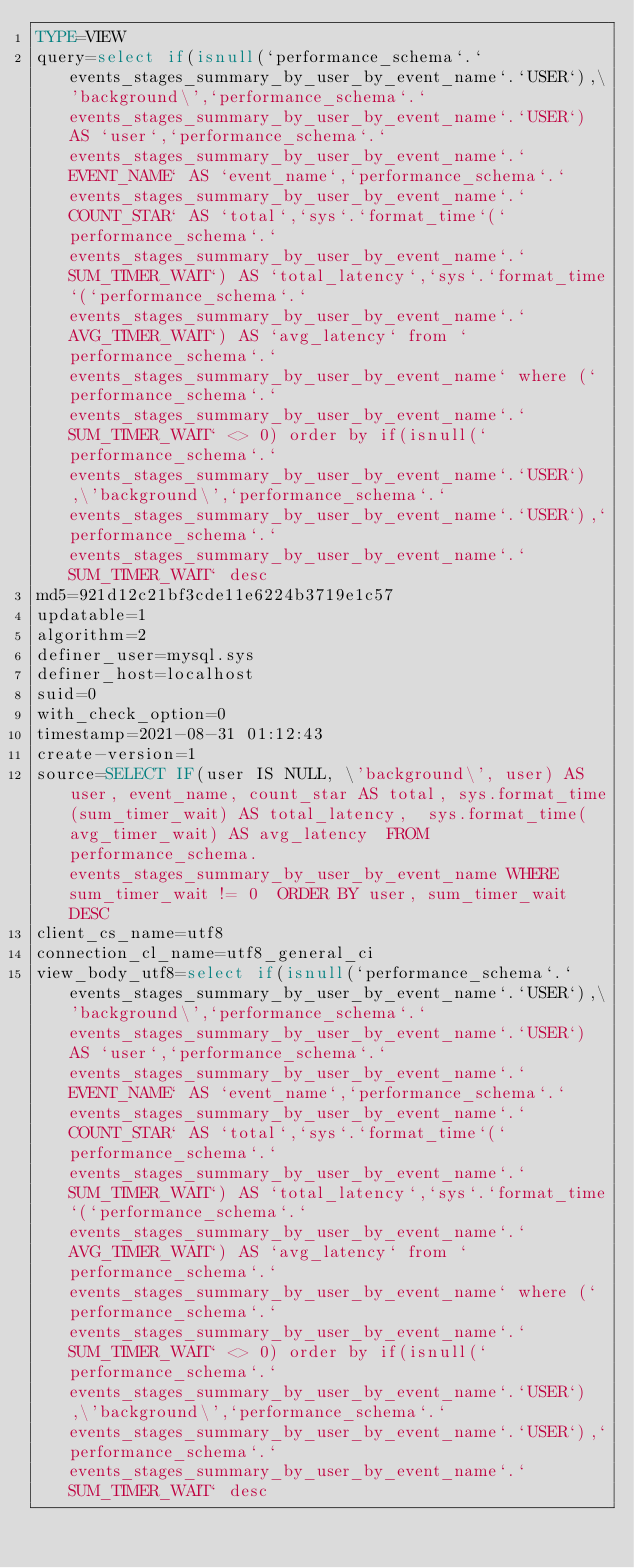Convert code to text. <code><loc_0><loc_0><loc_500><loc_500><_VisualBasic_>TYPE=VIEW
query=select if(isnull(`performance_schema`.`events_stages_summary_by_user_by_event_name`.`USER`),\'background\',`performance_schema`.`events_stages_summary_by_user_by_event_name`.`USER`) AS `user`,`performance_schema`.`events_stages_summary_by_user_by_event_name`.`EVENT_NAME` AS `event_name`,`performance_schema`.`events_stages_summary_by_user_by_event_name`.`COUNT_STAR` AS `total`,`sys`.`format_time`(`performance_schema`.`events_stages_summary_by_user_by_event_name`.`SUM_TIMER_WAIT`) AS `total_latency`,`sys`.`format_time`(`performance_schema`.`events_stages_summary_by_user_by_event_name`.`AVG_TIMER_WAIT`) AS `avg_latency` from `performance_schema`.`events_stages_summary_by_user_by_event_name` where (`performance_schema`.`events_stages_summary_by_user_by_event_name`.`SUM_TIMER_WAIT` <> 0) order by if(isnull(`performance_schema`.`events_stages_summary_by_user_by_event_name`.`USER`),\'background\',`performance_schema`.`events_stages_summary_by_user_by_event_name`.`USER`),`performance_schema`.`events_stages_summary_by_user_by_event_name`.`SUM_TIMER_WAIT` desc
md5=921d12c21bf3cde11e6224b3719e1c57
updatable=1
algorithm=2
definer_user=mysql.sys
definer_host=localhost
suid=0
with_check_option=0
timestamp=2021-08-31 01:12:43
create-version=1
source=SELECT IF(user IS NULL, \'background\', user) AS user, event_name, count_star AS total, sys.format_time(sum_timer_wait) AS total_latency,  sys.format_time(avg_timer_wait) AS avg_latency  FROM performance_schema.events_stages_summary_by_user_by_event_name WHERE sum_timer_wait != 0  ORDER BY user, sum_timer_wait DESC
client_cs_name=utf8
connection_cl_name=utf8_general_ci
view_body_utf8=select if(isnull(`performance_schema`.`events_stages_summary_by_user_by_event_name`.`USER`),\'background\',`performance_schema`.`events_stages_summary_by_user_by_event_name`.`USER`) AS `user`,`performance_schema`.`events_stages_summary_by_user_by_event_name`.`EVENT_NAME` AS `event_name`,`performance_schema`.`events_stages_summary_by_user_by_event_name`.`COUNT_STAR` AS `total`,`sys`.`format_time`(`performance_schema`.`events_stages_summary_by_user_by_event_name`.`SUM_TIMER_WAIT`) AS `total_latency`,`sys`.`format_time`(`performance_schema`.`events_stages_summary_by_user_by_event_name`.`AVG_TIMER_WAIT`) AS `avg_latency` from `performance_schema`.`events_stages_summary_by_user_by_event_name` where (`performance_schema`.`events_stages_summary_by_user_by_event_name`.`SUM_TIMER_WAIT` <> 0) order by if(isnull(`performance_schema`.`events_stages_summary_by_user_by_event_name`.`USER`),\'background\',`performance_schema`.`events_stages_summary_by_user_by_event_name`.`USER`),`performance_schema`.`events_stages_summary_by_user_by_event_name`.`SUM_TIMER_WAIT` desc
</code> 